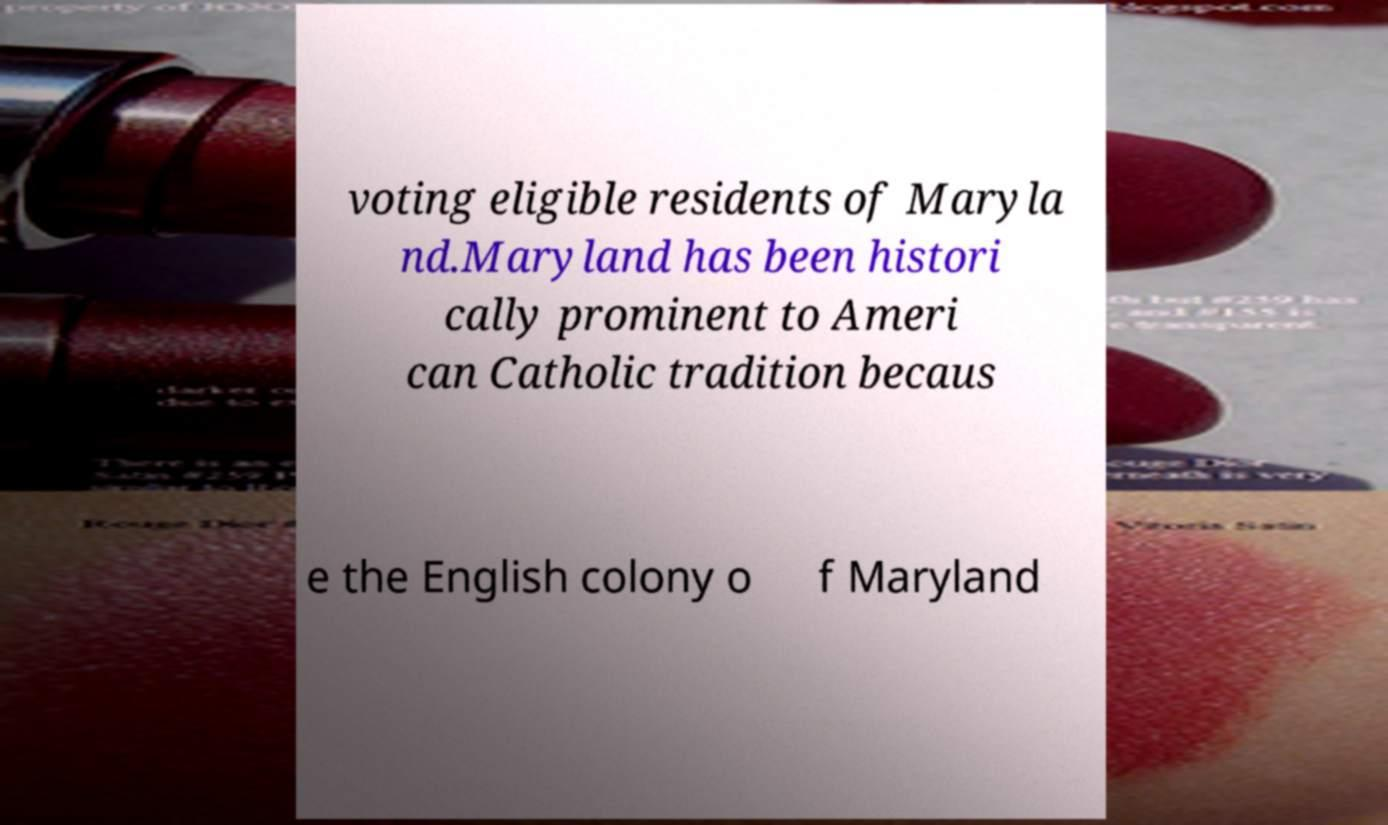Could you assist in decoding the text presented in this image and type it out clearly? voting eligible residents of Maryla nd.Maryland has been histori cally prominent to Ameri can Catholic tradition becaus e the English colony o f Maryland 